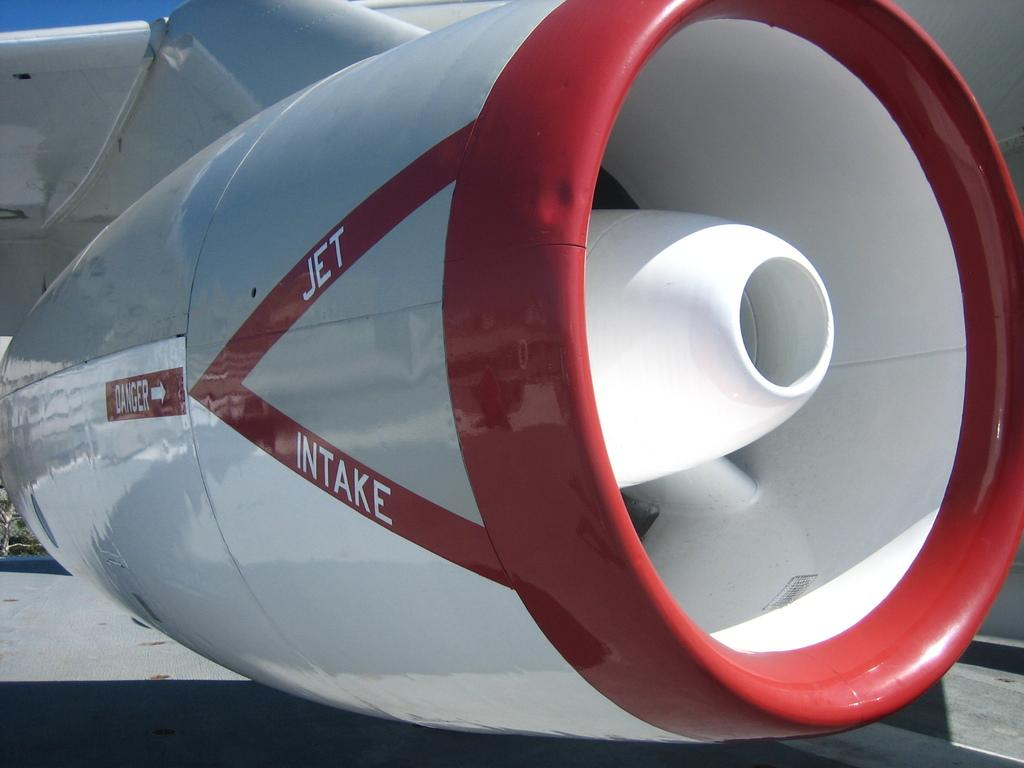<image>
Provide a brief description of the given image. a red and white engine on a jet intake plane 